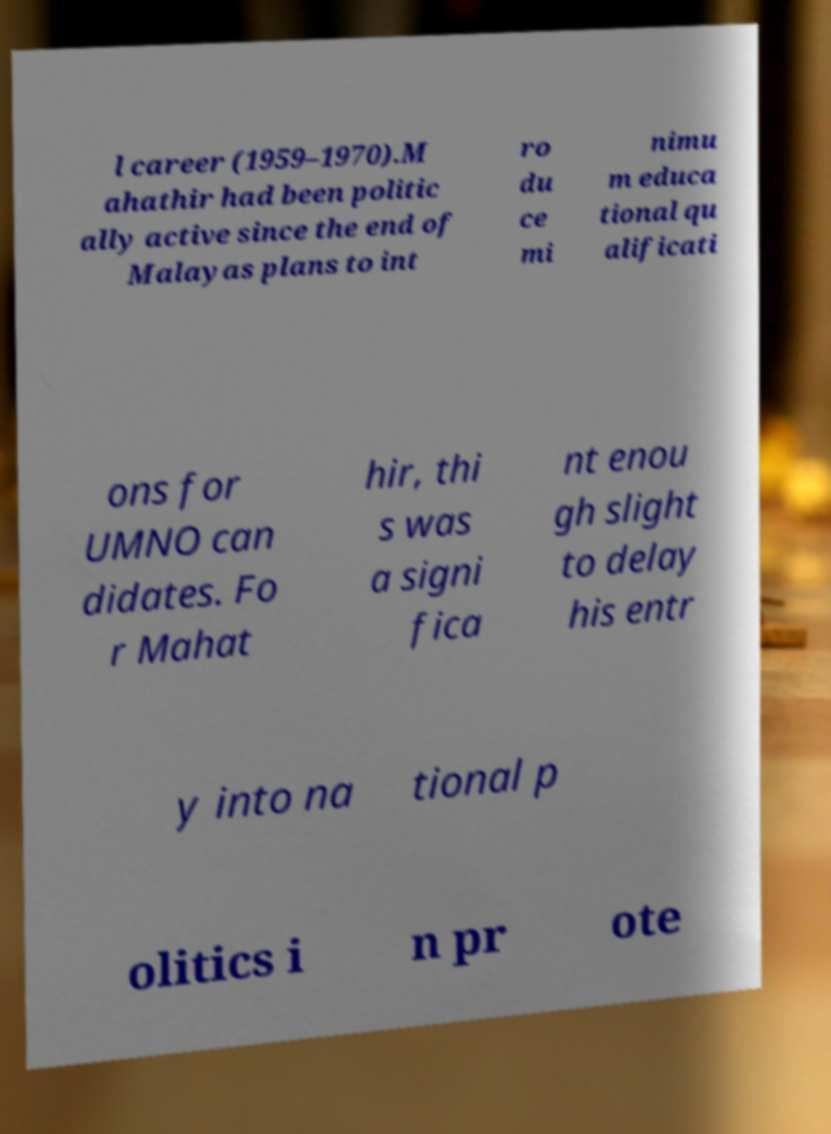Can you accurately transcribe the text from the provided image for me? l career (1959–1970).M ahathir had been politic ally active since the end of Malayas plans to int ro du ce mi nimu m educa tional qu alificati ons for UMNO can didates. Fo r Mahat hir, thi s was a signi fica nt enou gh slight to delay his entr y into na tional p olitics i n pr ote 